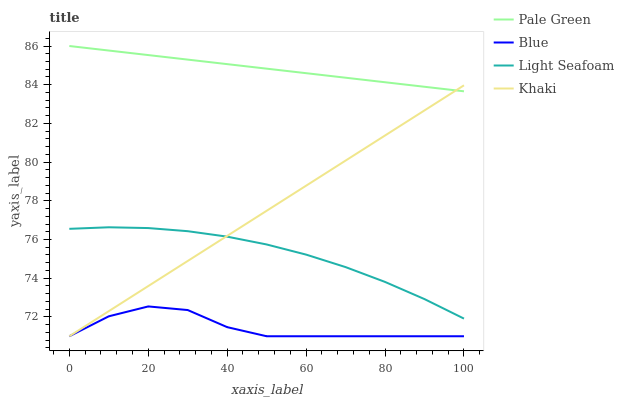Does Blue have the minimum area under the curve?
Answer yes or no. Yes. Does Pale Green have the maximum area under the curve?
Answer yes or no. Yes. Does Khaki have the minimum area under the curve?
Answer yes or no. No. Does Khaki have the maximum area under the curve?
Answer yes or no. No. Is Khaki the smoothest?
Answer yes or no. Yes. Is Blue the roughest?
Answer yes or no. Yes. Is Pale Green the smoothest?
Answer yes or no. No. Is Pale Green the roughest?
Answer yes or no. No. Does Blue have the lowest value?
Answer yes or no. Yes. Does Pale Green have the lowest value?
Answer yes or no. No. Does Pale Green have the highest value?
Answer yes or no. Yes. Does Khaki have the highest value?
Answer yes or no. No. Is Blue less than Pale Green?
Answer yes or no. Yes. Is Pale Green greater than Blue?
Answer yes or no. Yes. Does Khaki intersect Blue?
Answer yes or no. Yes. Is Khaki less than Blue?
Answer yes or no. No. Is Khaki greater than Blue?
Answer yes or no. No. Does Blue intersect Pale Green?
Answer yes or no. No. 